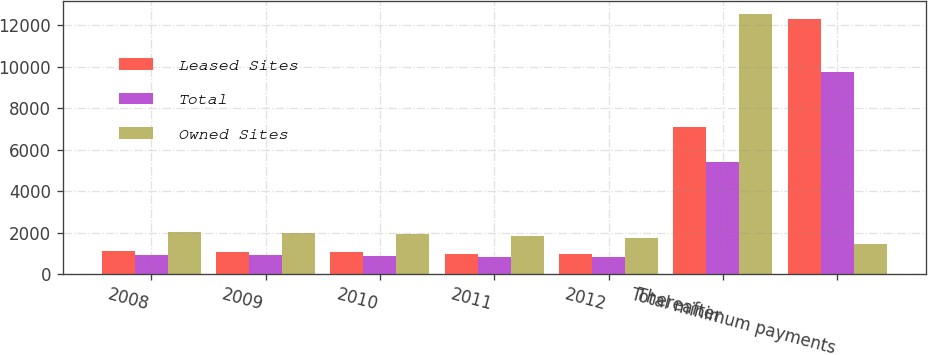Convert chart. <chart><loc_0><loc_0><loc_500><loc_500><stacked_bar_chart><ecel><fcel>2008<fcel>2009<fcel>2010<fcel>2011<fcel>2012<fcel>Thereafter<fcel>Total minimum payments<nl><fcel>Leased Sites<fcel>1120.1<fcel>1084.3<fcel>1045.2<fcel>995.6<fcel>959.3<fcel>7117.7<fcel>12322.2<nl><fcel>Total<fcel>933.4<fcel>905.8<fcel>874.5<fcel>838.2<fcel>809<fcel>5414.8<fcel>9775.7<nl><fcel>Owned Sites<fcel>2053.5<fcel>1990.1<fcel>1919.7<fcel>1833.8<fcel>1768.3<fcel>12532.5<fcel>1444.2<nl></chart> 